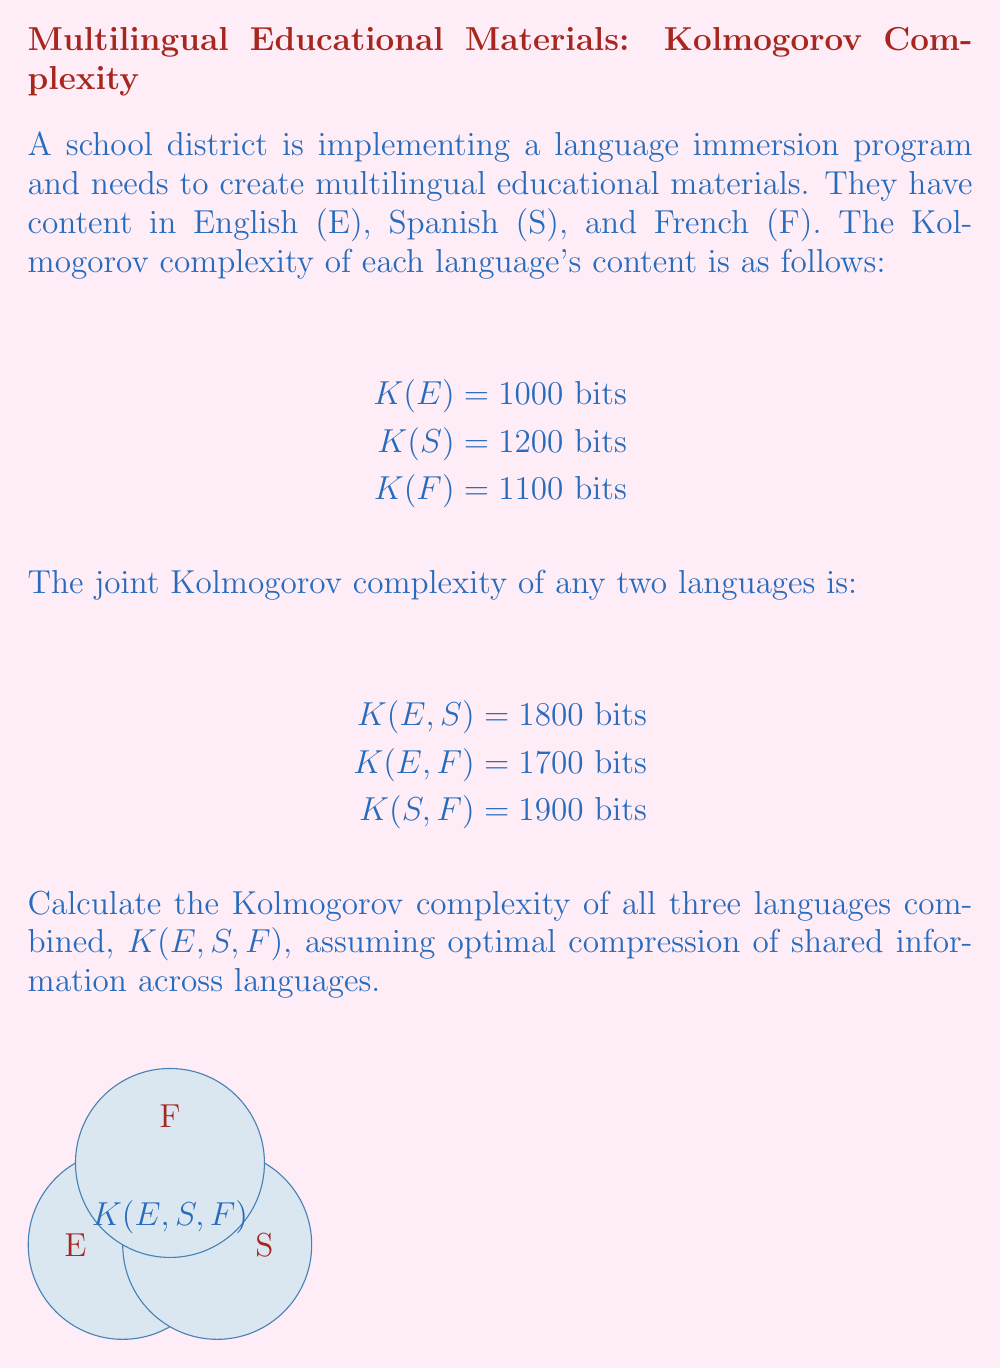Show me your answer to this math problem. To solve this problem, we'll use the concept of information content and the subadditivity property of Kolmogorov complexity. Let's approach this step-by-step:

1) First, let's calculate the total information content if we simply concatenated all three languages:
   $K(E) + K(S) + K(F) = 1000 + 1200 + 1100 = 3300$ bits

2) However, this doesn't account for shared information between languages. We can use the given joint complexities to calculate the shared information:

   Shared(E,S) = $K(E) + K(S) - K(E,S) = 1000 + 1200 - 1800 = 400$ bits
   Shared(E,F) = $K(E) + K(F) - K(E,F) = 1000 + 1100 - 1700 = 400$ bits
   Shared(S,F) = $K(S) + K(F) - K(S,F) = 1200 + 1100 - 1900 = 400$ bits

3) If we subtract all these shared information values from the total, we get:
   $3300 - 400 - 400 - 400 = 2100$ bits

4) However, this overcompensates for the shared information, as some of it might be shared among all three languages. Let's call this triple-shared information $x$.

5) We can set up an equation based on the inclusion-exclusion principle:
   $K(E,S,F) = K(E) + K(S) + K(F) - Shared(E,S) - Shared(E,F) - Shared(S,F) + x$

6) Substituting the known values:
   $K(E,S,F) = 1000 + 1200 + 1100 - 400 - 400 - 400 + x = 2100 + x$

7) While we don't know the exact value of $x$, we know it must be non-negative (as it represents information content) and it can't exceed the minimum shared information between any two languages (400 bits in this case).

8) Therefore, the Kolmogorov complexity $K(E,S,F)$ must be between 2100 and 2500 bits.

9) Without more information, we can't determine the exact value, but we can express it as $2100 + x$, where $0 \leq x \leq 400$.
Answer: $K(E,S,F) = 2100 + x$, where $0 \leq x \leq 400$ 